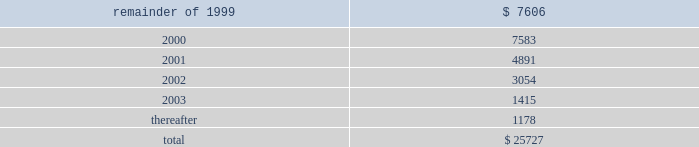The containerboard group ( a division of tenneco packaging inc. ) notes to combined financial statements ( continued ) april 11 , 1999 14 .
Leases ( continued ) to the sale transaction on april 12 , 1999 .
Therefore , the remaining outstanding aggregate minimum rental commitments under noncancelable operating leases are as follows : ( in thousands ) .
15 .
Sale of assets in the second quarter of 1996 , packaging entered into an agreement to form a joint venture with caraustar industries whereby packaging sold its two recycled paperboard mills and a fiber recycling operation and brokerage business to the joint venture in return for cash and a 20% ( 20 % ) equity interest in the joint venture .
Proceeds from the sale were approximately $ 115 million and the group recognized a $ 50 million pretax gain ( $ 30 million after taxes ) in the second quarter of 1996 .
In june , 1998 , packaging sold its remaining 20% ( 20 % ) equity interest in the joint venture to caraustar industries for cash and a note of $ 26000000 .
The group recognized a $ 15 million pretax gain on this transaction .
At april 11 , 1999 , the balance of the note with accrued interest is $ 27122000 .
The note was paid in june , 1999 .
16 .
Subsequent events on august 25 , 1999 , pca and packaging agreed that the acquisition consideration should be reduced as a result of a postclosing price adjustment by an amount equal to $ 20 million plus interest through the date of payment by packaging .
The group recorded $ 11.9 million of this amount as part of the impairment charge on the accompanying financial statements , representing the amount that was previously estimated by packaging .
Pca intends to record the remaining amount in september , 1999 .
In august , 1999 , pca signed purchase and sales agreements with various buyers to sell approximately 405000 acres of timberland .
Pca has completed the sale of approximately 260000 of these acres and expects to complete the sale of the remaining acres by mid-november , 1999. .
What was the total in thousands in minimum rental payments in 2000 and 2001? 
Computations: (7583 + 4891)
Answer: 12474.0. 